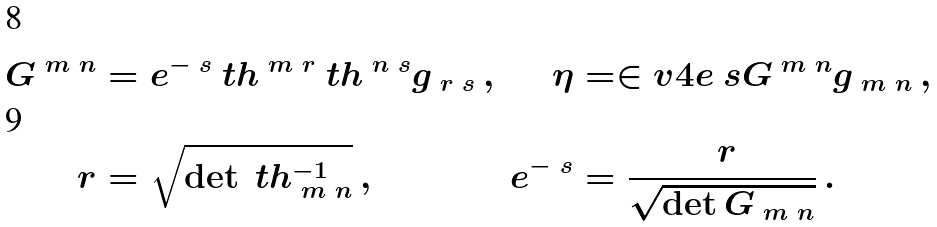Convert formula to latex. <formula><loc_0><loc_0><loc_500><loc_500>G ^ { \ m \ n } & = e ^ { - \ s } \ t h ^ { \ m \ r } \ t h ^ { \ n \ s } g _ { \ r \ s } \, , & \eta & = \in v { 4 } e ^ { \ } s G ^ { \ m \ n } g _ { \ m \ n } \, , \\ \ r & = \sqrt { \det { \ t h ^ { - 1 } _ { \ m \ n } } } \, , & e ^ { - \ s } & = \frac { \ r } { \sqrt { \det { G _ { \ m \ n } } } } \, .</formula> 